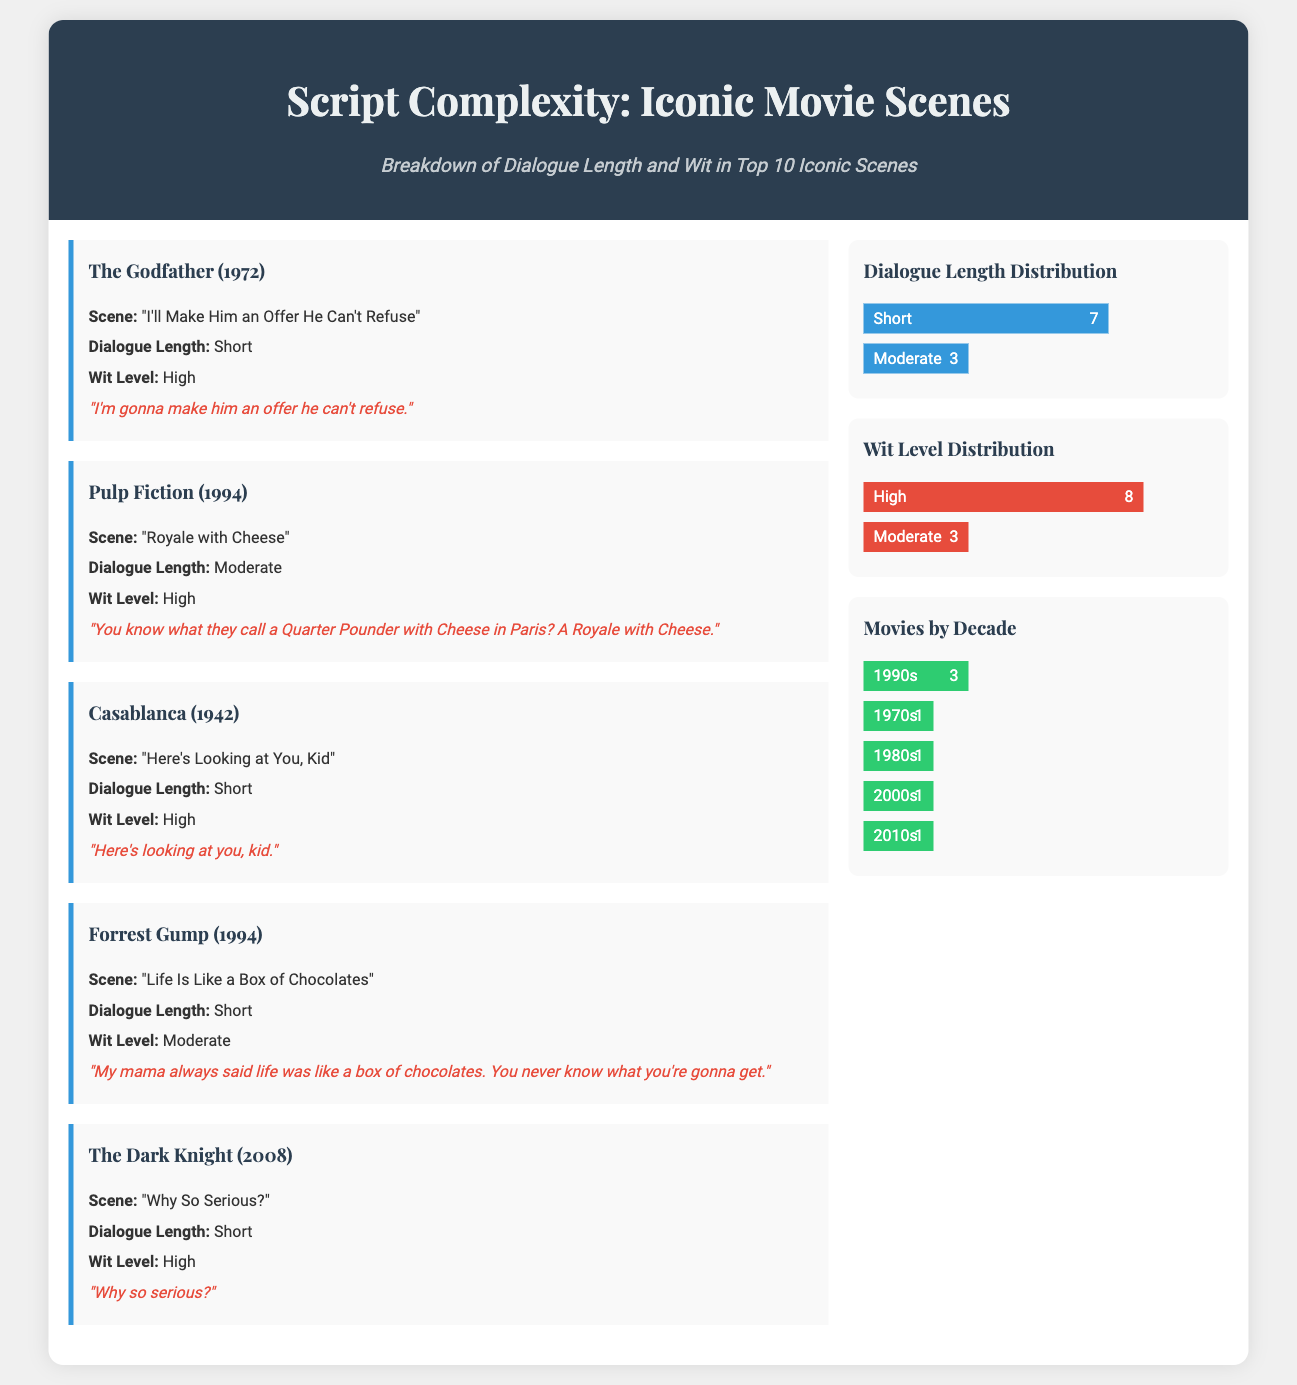What is the title of the infographic? The title of the infographic is prominently displayed at the top of the document, which is "Script Complexity: Iconic Movie Scenes".
Answer: Script Complexity: Iconic Movie Scenes How many scenes have a short dialogue length? The document provides a breakdown of dialogue lengths where "Short" is labeled alongside 7 scenes.
Answer: 7 Which movie scene has a high wit level and short dialogue? The scene from "The Dark Knight (2008)" featuring the line "Why so serious?" is identified as high in wit and short in dialogue length.
Answer: The Dark Knight (2008) What percentage of scenes have a high wit level? The infographic shows that 80% of the scenes are classified under high wit level according to the wit level distribution.
Answer: 80% Which decade has the most scenes represented in the infographic? The data shows that the 1990s have the most representation with 3 scenes listed.
Answer: 1990s What is the iconic line from "Casablanca"? The document provides the famous line, which is "Here's looking at you, kid."
Answer: Here's looking at you, kid How many movies were released in the 2000s? The statistics indicate that there is 1 movie from the decade of the 2000s represented in the infographic.
Answer: 1 What is the dialogue length classification for "Pulp Fiction"? The dialogue length for "Pulp Fiction" is classified as moderate according to the scene description.
Answer: Moderate Which movie from the 1970s is mentioned in the document? The only movie listed from the 1970s is "The Godfather (1972)".
Answer: The Godfather (1972) 